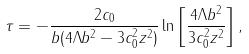<formula> <loc_0><loc_0><loc_500><loc_500>\tau = - \frac { 2 c _ { 0 } } { b ( 4 \Lambda b ^ { 2 } - 3 c _ { 0 } ^ { 2 } z ^ { 2 } ) } \ln \left [ \frac { 4 \Lambda b ^ { 2 } } { 3 c _ { 0 } ^ { 2 } z ^ { 2 } } \right ] ,</formula> 